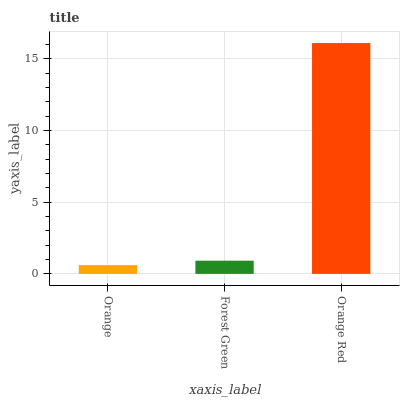Is Forest Green the minimum?
Answer yes or no. No. Is Forest Green the maximum?
Answer yes or no. No. Is Forest Green greater than Orange?
Answer yes or no. Yes. Is Orange less than Forest Green?
Answer yes or no. Yes. Is Orange greater than Forest Green?
Answer yes or no. No. Is Forest Green less than Orange?
Answer yes or no. No. Is Forest Green the high median?
Answer yes or no. Yes. Is Forest Green the low median?
Answer yes or no. Yes. Is Orange the high median?
Answer yes or no. No. Is Orange the low median?
Answer yes or no. No. 